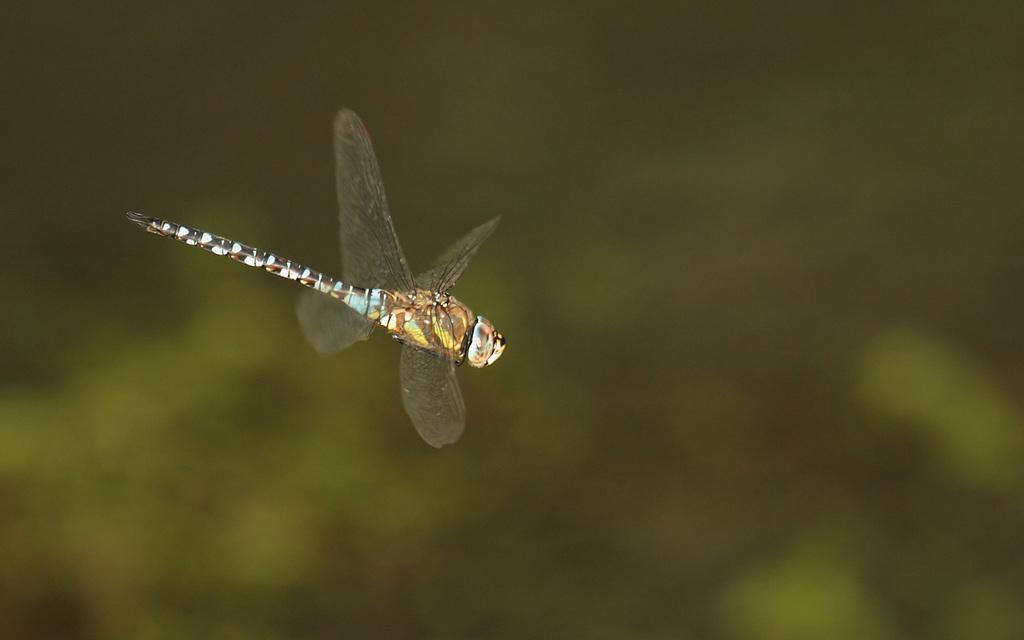What is the main subject of the picture? The main subject of the picture is a dragonfly. Can you describe the background of the image? The background of the image is blurry. How many clouds can be seen in the image? There are no clouds visible in the image, as it features a dragonfly and a blurry background. What type of insects are crawling on the star in the image? There is no star or insects present in the image; it features a dragonfly and a blurry background. 